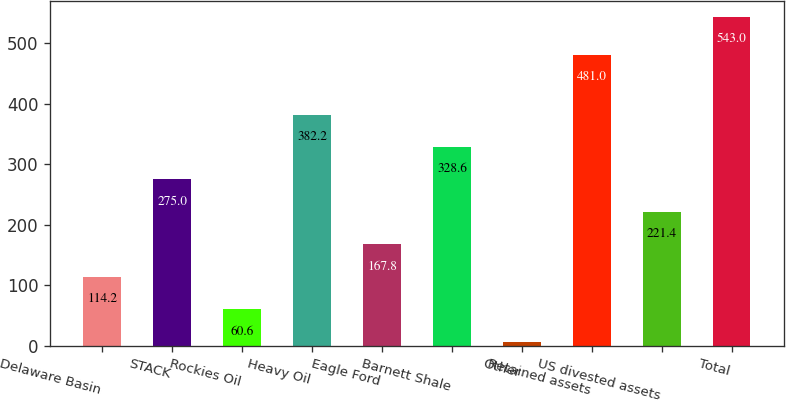Convert chart to OTSL. <chart><loc_0><loc_0><loc_500><loc_500><bar_chart><fcel>Delaware Basin<fcel>STACK<fcel>Rockies Oil<fcel>Heavy Oil<fcel>Eagle Ford<fcel>Barnett Shale<fcel>Other<fcel>Retained assets<fcel>US divested assets<fcel>Total<nl><fcel>114.2<fcel>275<fcel>60.6<fcel>382.2<fcel>167.8<fcel>328.6<fcel>7<fcel>481<fcel>221.4<fcel>543<nl></chart> 